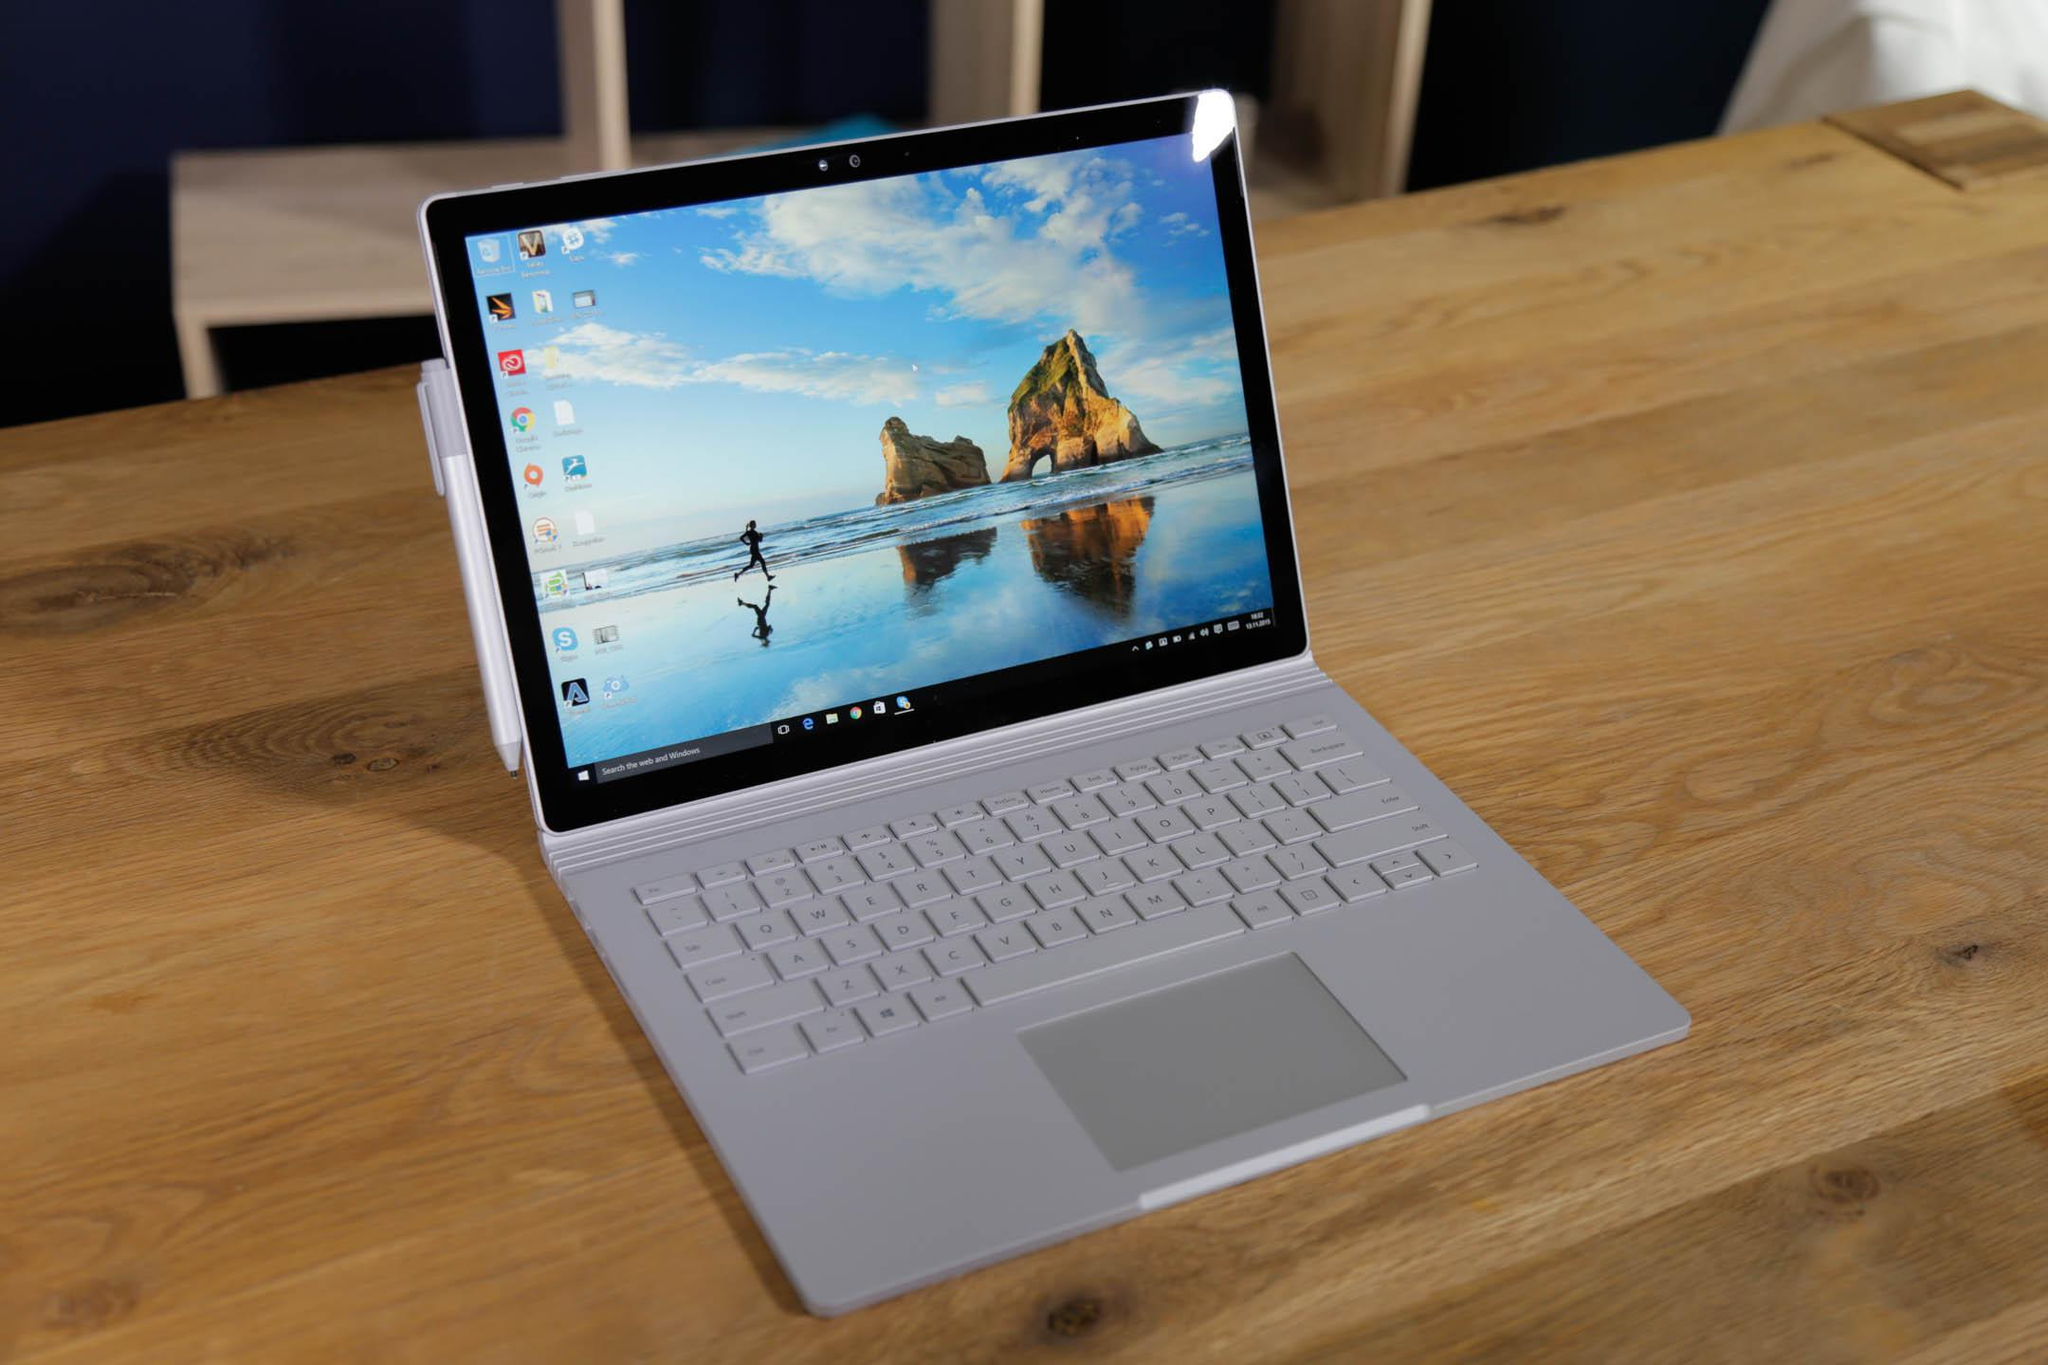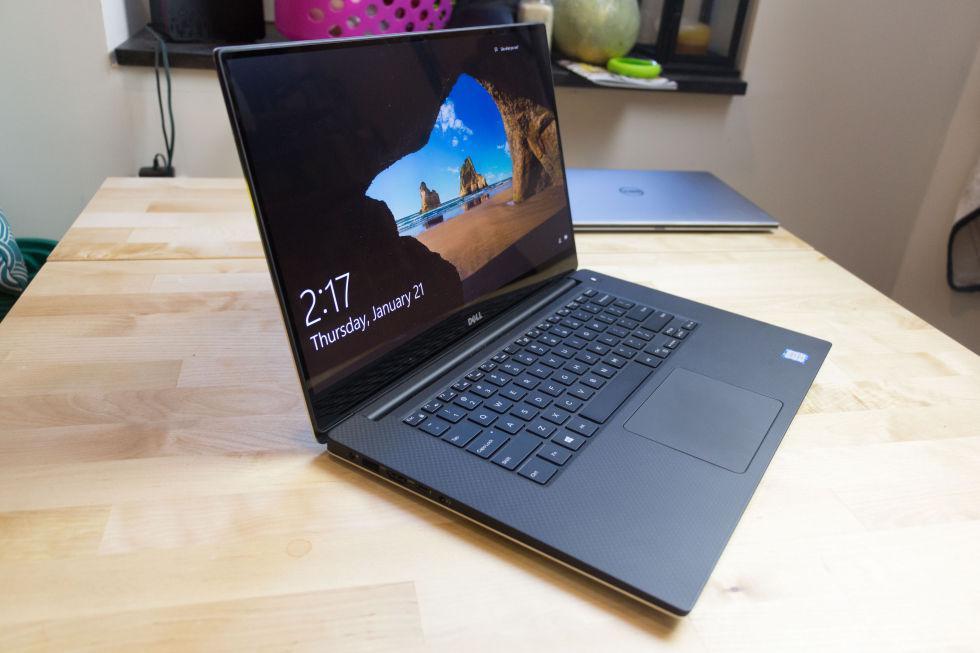The first image is the image on the left, the second image is the image on the right. Analyze the images presented: Is the assertion "At least one image contains two open laptops, and the left image includes a laptop with a peacock displayed on its screen." valid? Answer yes or no. No. 